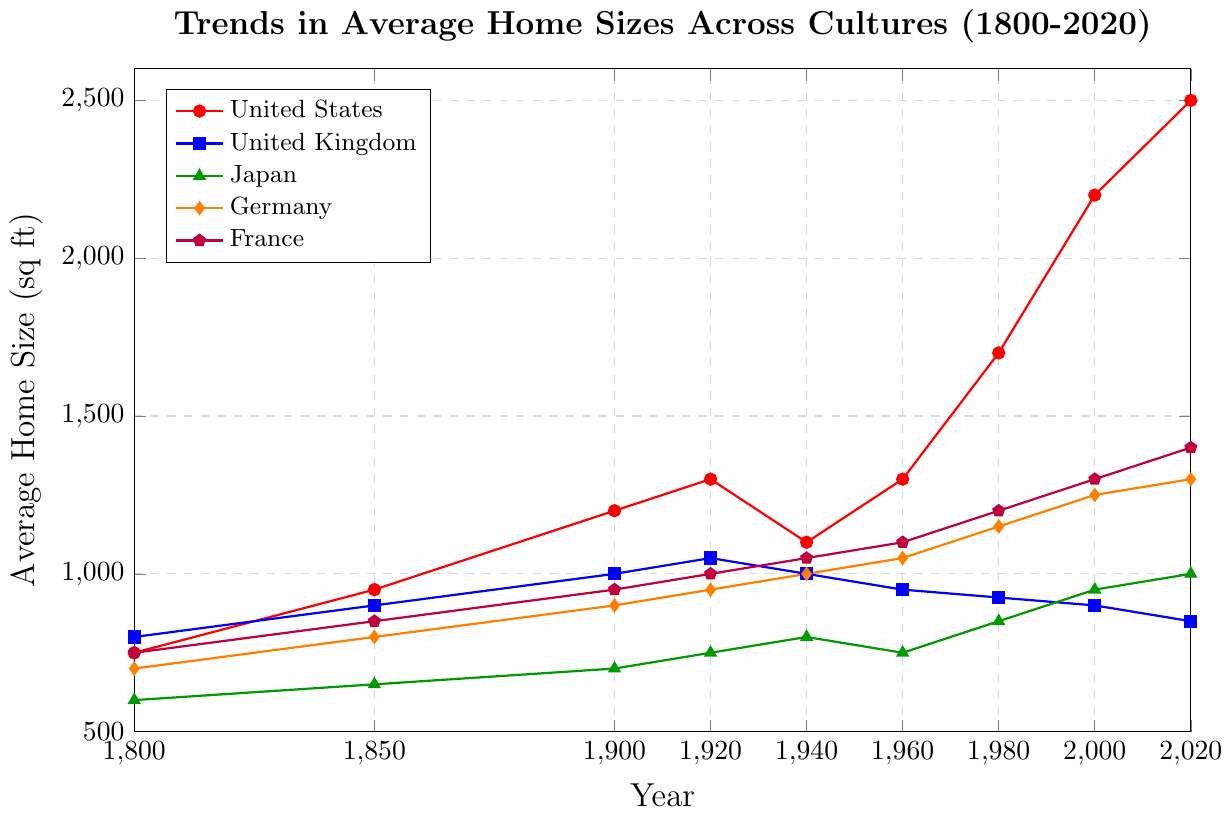What is the average home size in France in 1980? The figure shows the home size in France in 1980 as 1200 sq ft.
Answer: 1200 sq ft Which country had the largest home size in 2020? Observing the figure, home sizes in 2020 for each country show the United States with the largest at 2500 sq ft.
Answer: United States What is the difference in average home size between the United States and the United Kingdom in 2000? The figure outlines home sizes in 2000: United States (2200 sq ft) and the United Kingdom (900 sq ft). The difference is 2200 - 900 = 1300 sq ft.
Answer: 1300 sq ft By how much did the average home size increase in Germany from 1800 to 2020? In 1800, Germany's average home size was 700 sq ft, and in 2020 it was 1300 sq ft. The increase is 1300 - 700 = 600 sq ft.
Answer: 600 sq ft Which countries had a decrease in the average home size from 1960 to 2020? From 1960 to 2020, the United Kingdom (950 to 850 sq ft) experienced a decrease in home size. Other countries increased or remained mostly the same.
Answer: United Kingdom What are the trends observed in Japan's average home sizes from 1800 to 2020? Examining the plot, Japan's home sizes consistently increased over time: 600 (1800), 650 (1850), 700 (1900), 750 (1920), 800 (1940), 750 (1960), 850 (1980), 950 (2000), 1000 (2020).
Answer: Consistent increase What is the closest average home size between Germany and France in any given year? In 1800, both Germany and France had close average home sizes: Germany (700 sq ft), France (750 sq ft), with only a 50 sq ft difference.
Answer: 1800 What general trend can be inferred about the average home size in the United States from 1800 to 2020? From the figure, average home sizes in the United States show a significant and consistent upward trend starting from 750 sq ft in 1800 to 2500 sq ft in 2020.
Answer: Significant upward trend Which country experienced the smallest change in average home size between 1800 and 2020? The United Kingdom had home sizes of 800 sq ft in 1800 and 850 sq ft in 2020. The change is minimal compared to other countries.
Answer: United Kingdom Between which two consecutive periods did France experience the largest increase in home size? France's home size increased most significantly between 1800 (750 sq ft) and 1850 (850 sq ft), with a 100 sq ft increase.
Answer: 1800 to 1850 